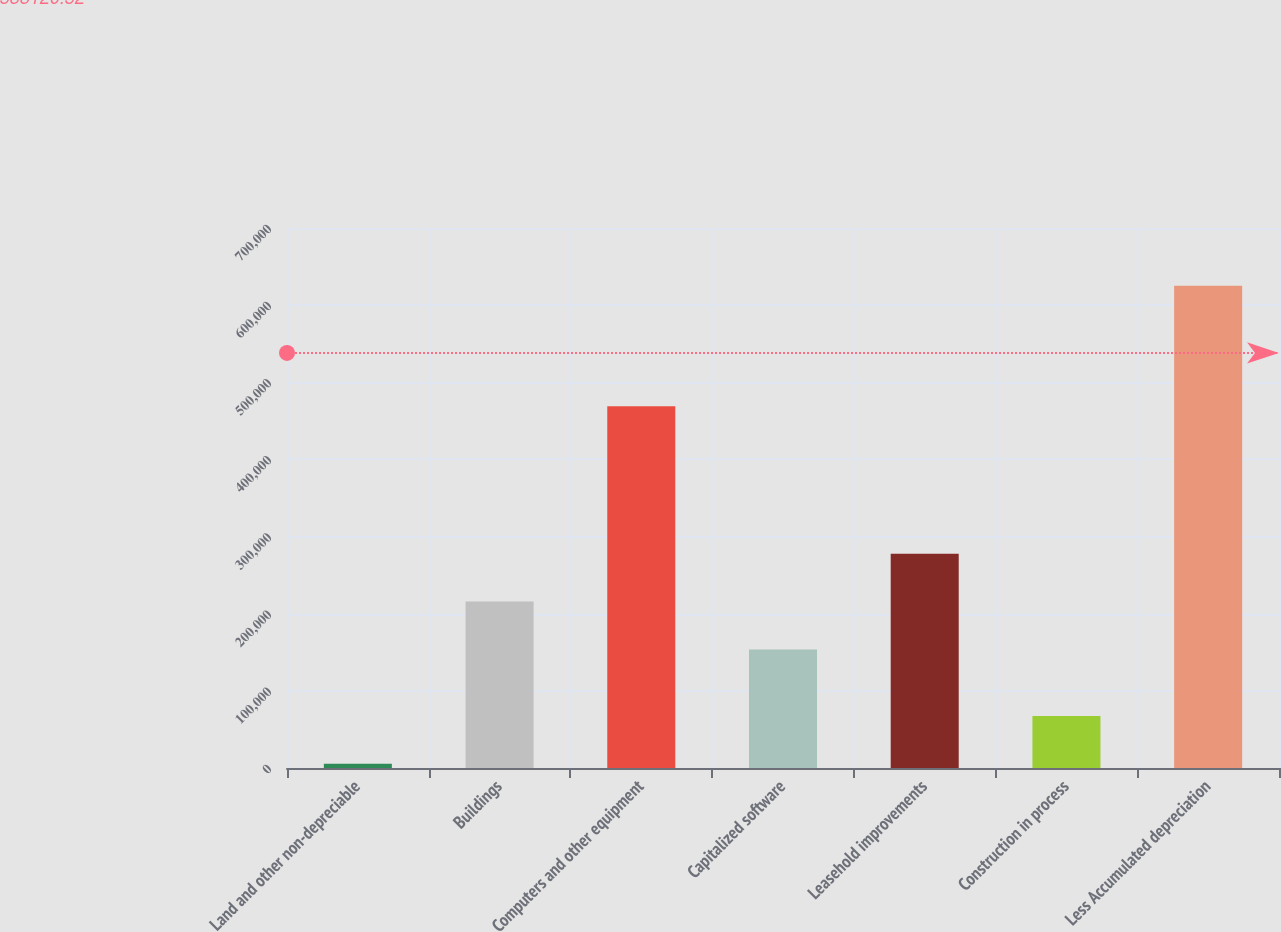Convert chart to OTSL. <chart><loc_0><loc_0><loc_500><loc_500><bar_chart><fcel>Land and other non-depreciable<fcel>Buildings<fcel>Computers and other equipment<fcel>Capitalized software<fcel>Leasehold improvements<fcel>Construction in process<fcel>Less Accumulated depreciation<nl><fcel>5353<fcel>215743<fcel>469066<fcel>153771<fcel>277715<fcel>67325.2<fcel>625075<nl></chart> 